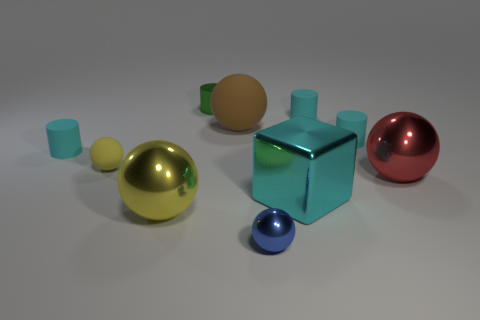How many cyan cylinders must be subtracted to get 1 cyan cylinders? 2 Subtract all brown cubes. How many cyan cylinders are left? 3 Subtract 1 cylinders. How many cylinders are left? 3 Subtract all gray balls. Subtract all cyan cylinders. How many balls are left? 5 Subtract all cubes. How many objects are left? 9 Add 8 large yellow metal balls. How many large yellow metal balls are left? 9 Add 2 tiny gray metal spheres. How many tiny gray metal spheres exist? 2 Subtract 1 red spheres. How many objects are left? 9 Subtract all large blue rubber things. Subtract all brown balls. How many objects are left? 9 